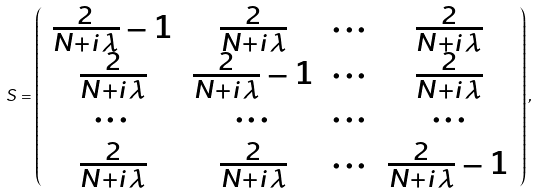<formula> <loc_0><loc_0><loc_500><loc_500>S = \left ( \begin{array} { c c c c } \frac { 2 } { N + i \lambda } - 1 & \frac { 2 } { N + i \lambda } & \cdots & \frac { 2 } { N + i \lambda } \\ \frac { 2 } { N + i \lambda } & \frac { 2 } { N + i \lambda } - 1 & \cdots & \frac { 2 } { N + i \lambda } \\ \cdots & \cdots & \cdots & \cdots \\ \frac { 2 } { N + i \lambda } & \frac { 2 } { N + i \lambda } & \cdots & \frac { 2 } { N + i \lambda } - 1 \end{array} \right ) ,</formula> 